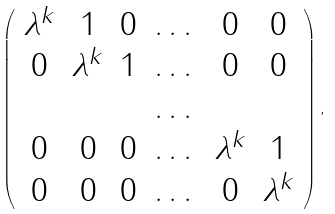<formula> <loc_0><loc_0><loc_500><loc_500>\left ( \begin{array} { c c c c c c } \lambda ^ { k } & 1 & 0 & \dots & 0 & 0 \\ 0 & \lambda ^ { k } & 1 & \dots & 0 & 0 \\ & & & \dots & & \\ 0 & 0 & 0 & \dots & \lambda ^ { k } & 1 \\ 0 & 0 & 0 & \dots & 0 & \lambda ^ { k } \end{array} \right ) ,</formula> 